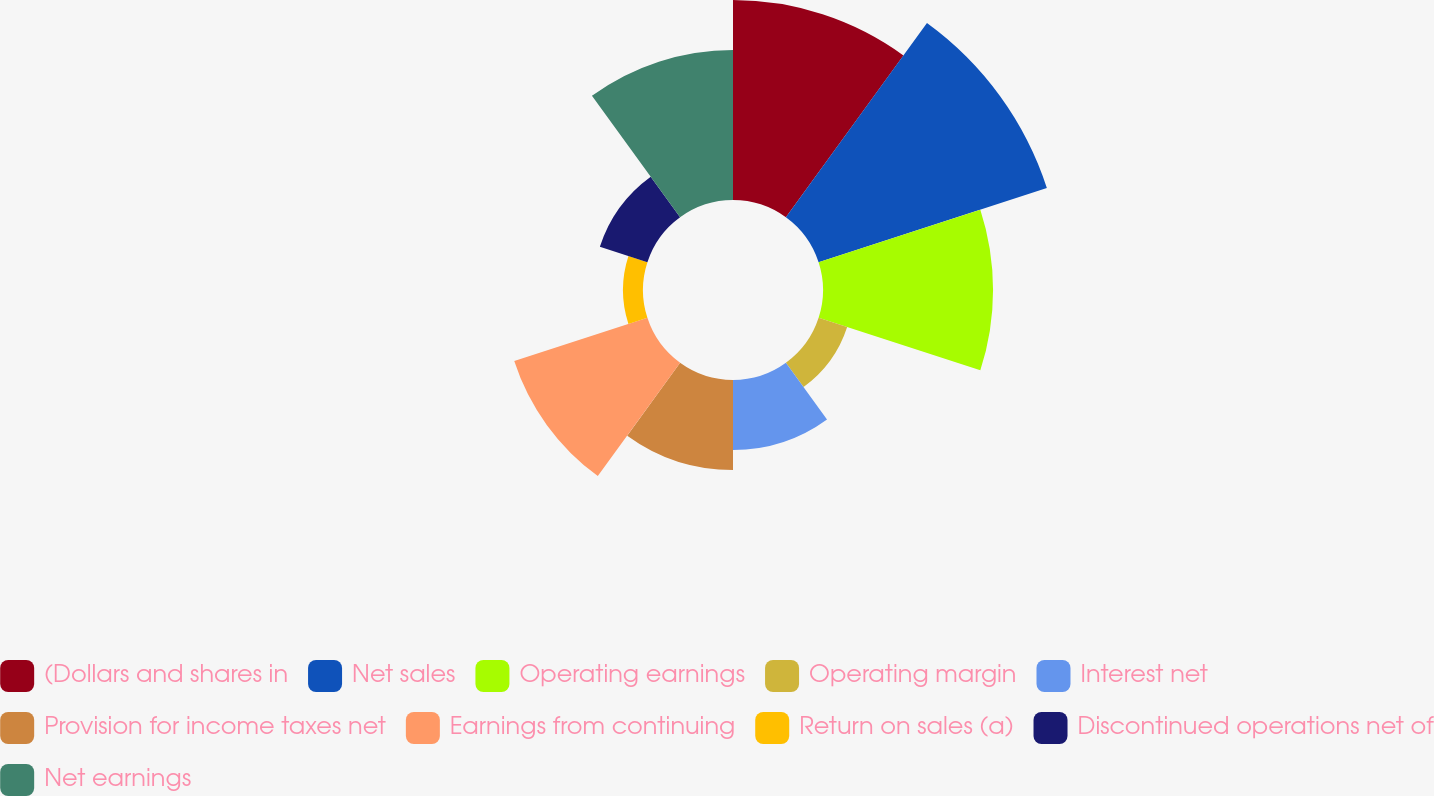Convert chart to OTSL. <chart><loc_0><loc_0><loc_500><loc_500><pie_chart><fcel>(Dollars and shares in<fcel>Net sales<fcel>Operating earnings<fcel>Operating margin<fcel>Interest net<fcel>Provision for income taxes net<fcel>Earnings from continuing<fcel>Return on sales (a)<fcel>Discontinued operations net of<fcel>Net earnings<nl><fcel>17.24%<fcel>20.69%<fcel>14.66%<fcel>2.59%<fcel>6.03%<fcel>7.76%<fcel>12.07%<fcel>1.72%<fcel>4.31%<fcel>12.93%<nl></chart> 